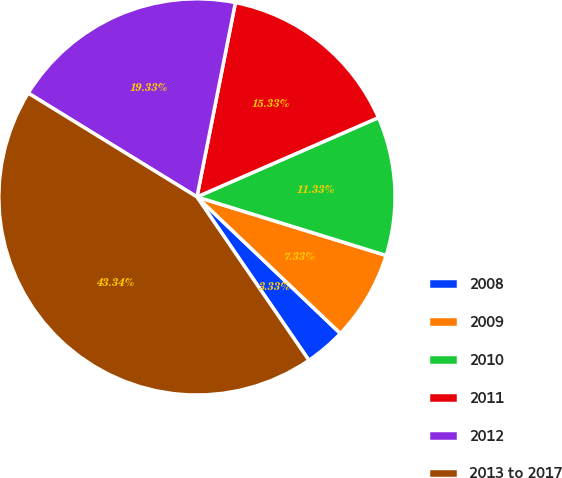<chart> <loc_0><loc_0><loc_500><loc_500><pie_chart><fcel>2008<fcel>2009<fcel>2010<fcel>2011<fcel>2012<fcel>2013 to 2017<nl><fcel>3.33%<fcel>7.33%<fcel>11.33%<fcel>15.33%<fcel>19.33%<fcel>43.33%<nl></chart> 